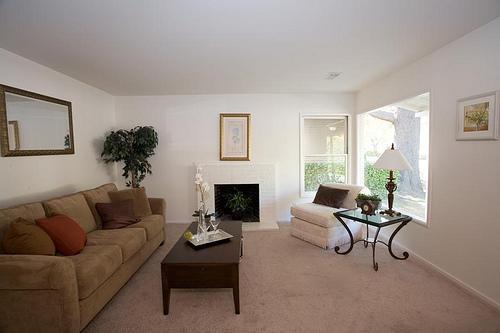How many couch pillows are there?
Give a very brief answer. 4. How many items are hanging on the walls?
Give a very brief answer. 3. How many tables are in the room?
Give a very brief answer. 2. How many sofas are in the room?
Give a very brief answer. 1. How many pillows are on the couch?
Give a very brief answer. 4. 